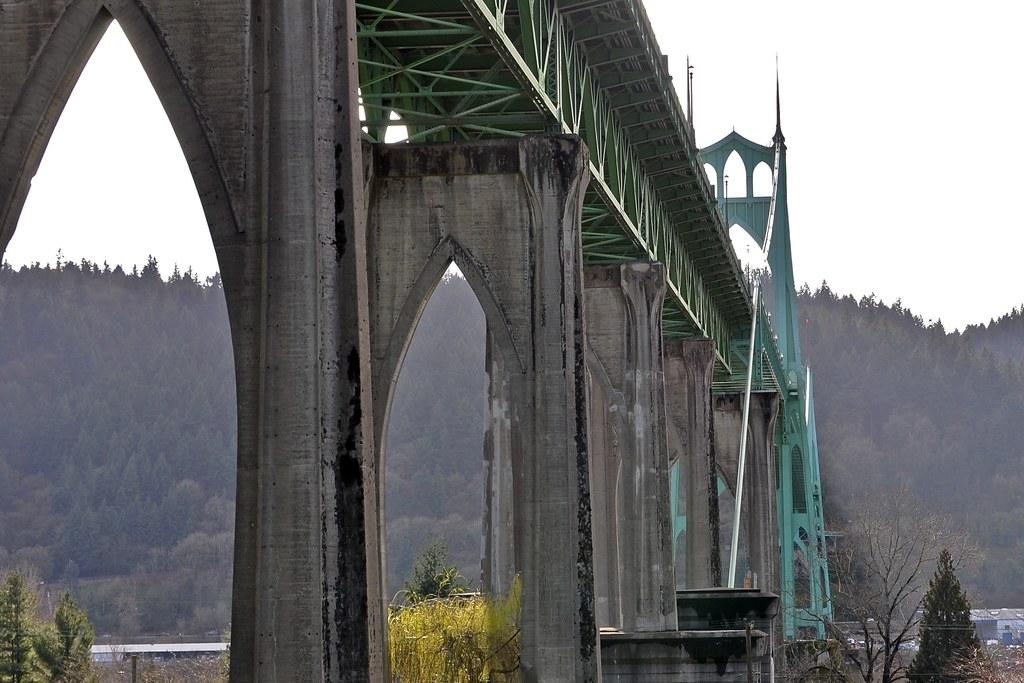What structure is located at the front of the image? There is a bridge in the front of the image. What type of vegetation can be seen in the image? There are plants in the image. What is visible in the background of the image? There are trees and a cloudy sky in the background of the image. What type of buildings are present in the image? There are houses in the center of the image. What type of brush is being used to prepare the feast in the image? There is no feast or brush present in the image. Can you tell me where the father is located in the image? There is no father or any person present in the image. 